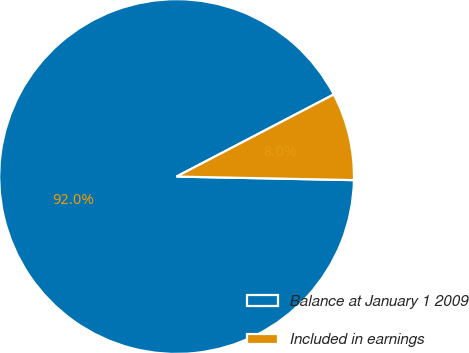Convert chart to OTSL. <chart><loc_0><loc_0><loc_500><loc_500><pie_chart><fcel>Balance at January 1 2009<fcel>Included in earnings<nl><fcel>92.02%<fcel>7.98%<nl></chart> 